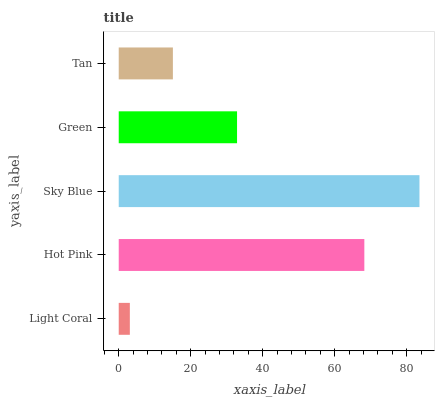Is Light Coral the minimum?
Answer yes or no. Yes. Is Sky Blue the maximum?
Answer yes or no. Yes. Is Hot Pink the minimum?
Answer yes or no. No. Is Hot Pink the maximum?
Answer yes or no. No. Is Hot Pink greater than Light Coral?
Answer yes or no. Yes. Is Light Coral less than Hot Pink?
Answer yes or no. Yes. Is Light Coral greater than Hot Pink?
Answer yes or no. No. Is Hot Pink less than Light Coral?
Answer yes or no. No. Is Green the high median?
Answer yes or no. Yes. Is Green the low median?
Answer yes or no. Yes. Is Hot Pink the high median?
Answer yes or no. No. Is Hot Pink the low median?
Answer yes or no. No. 